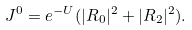Convert formula to latex. <formula><loc_0><loc_0><loc_500><loc_500>J ^ { 0 } & = e ^ { - U } ( | R _ { 0 } | ^ { 2 } + | R _ { 2 } | ^ { 2 } ) .</formula> 